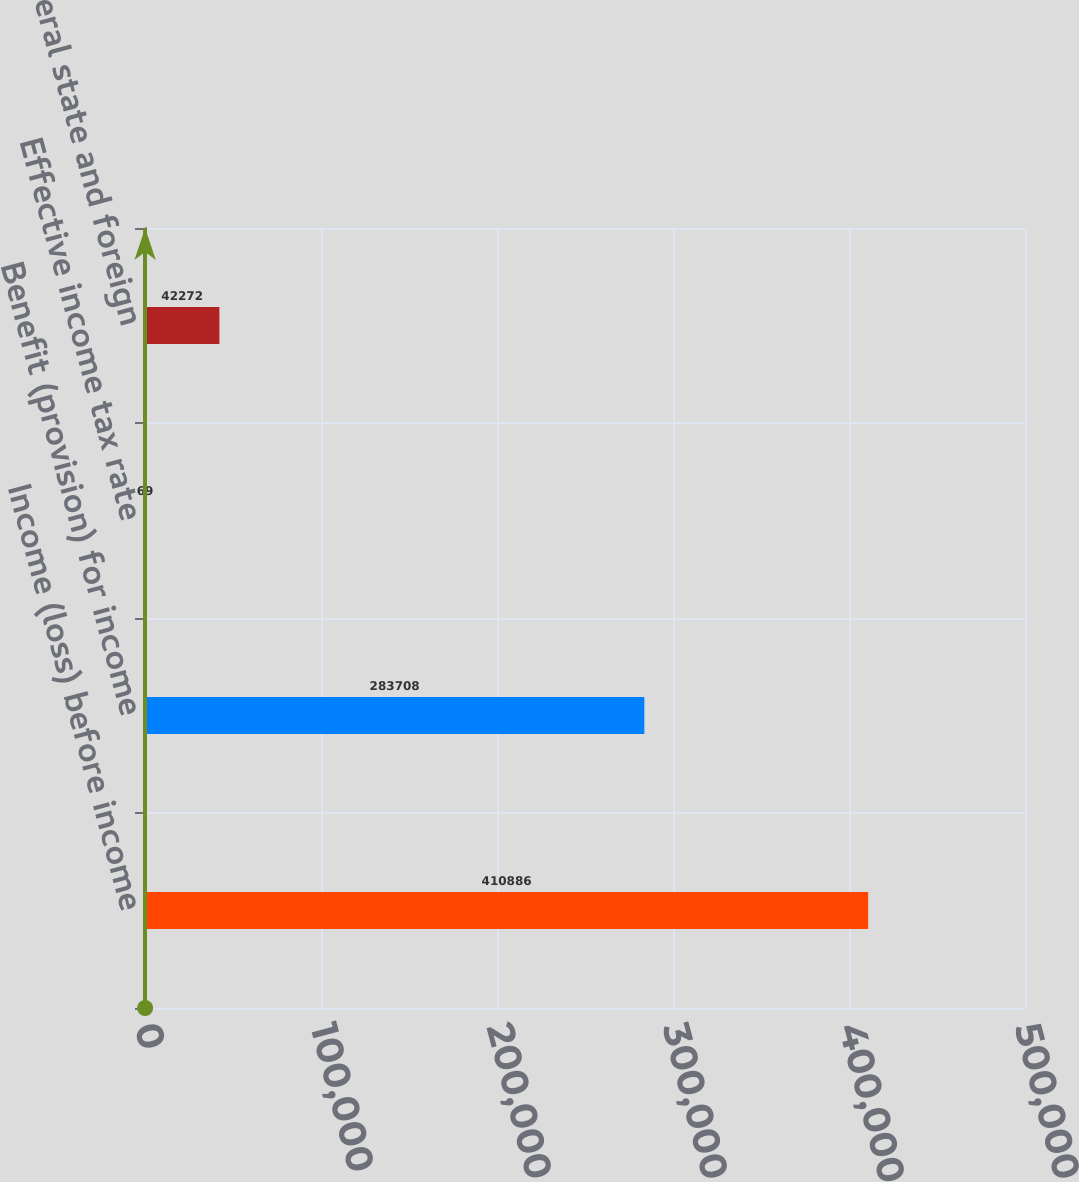Convert chart to OTSL. <chart><loc_0><loc_0><loc_500><loc_500><bar_chart><fcel>Income (loss) before income<fcel>Benefit (provision) for income<fcel>Effective income tax rate<fcel>Federal state and foreign<nl><fcel>410886<fcel>283708<fcel>69<fcel>42272<nl></chart> 